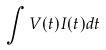<formula> <loc_0><loc_0><loc_500><loc_500>\int V ( t ) I ( t ) d t</formula> 